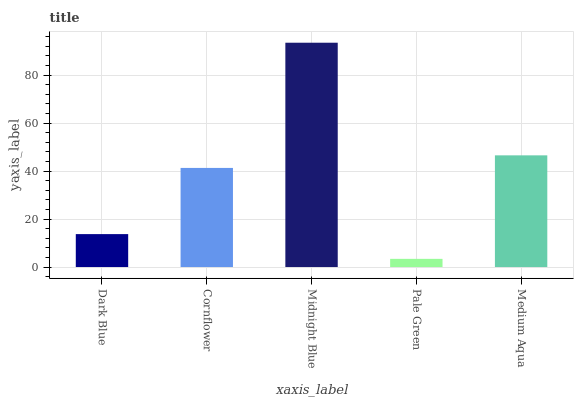Is Pale Green the minimum?
Answer yes or no. Yes. Is Midnight Blue the maximum?
Answer yes or no. Yes. Is Cornflower the minimum?
Answer yes or no. No. Is Cornflower the maximum?
Answer yes or no. No. Is Cornflower greater than Dark Blue?
Answer yes or no. Yes. Is Dark Blue less than Cornflower?
Answer yes or no. Yes. Is Dark Blue greater than Cornflower?
Answer yes or no. No. Is Cornflower less than Dark Blue?
Answer yes or no. No. Is Cornflower the high median?
Answer yes or no. Yes. Is Cornflower the low median?
Answer yes or no. Yes. Is Medium Aqua the high median?
Answer yes or no. No. Is Dark Blue the low median?
Answer yes or no. No. 